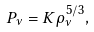Convert formula to latex. <formula><loc_0><loc_0><loc_500><loc_500>P _ { \nu } = K \rho _ { \nu } ^ { 5 / 3 } ,</formula> 